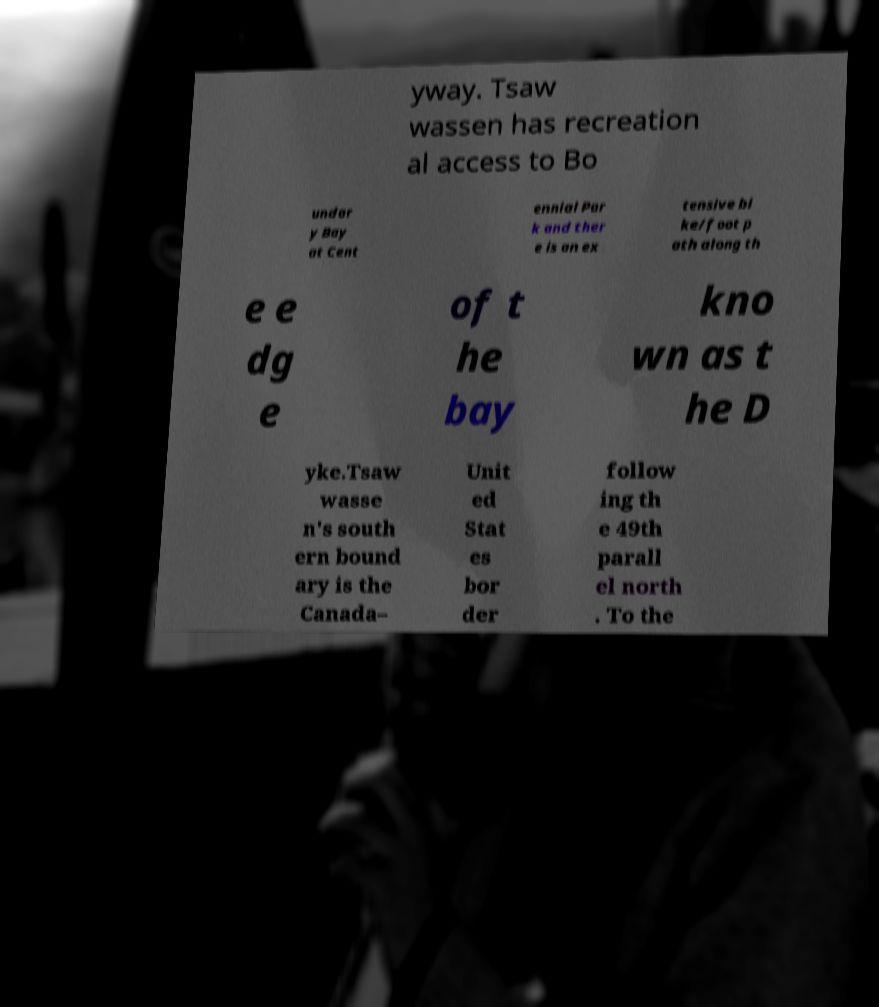Please identify and transcribe the text found in this image. yway. Tsaw wassen has recreation al access to Bo undar y Bay at Cent ennial Par k and ther e is an ex tensive bi ke/foot p ath along th e e dg e of t he bay kno wn as t he D yke.Tsaw wasse n's south ern bound ary is the Canada– Unit ed Stat es bor der follow ing th e 49th parall el north . To the 